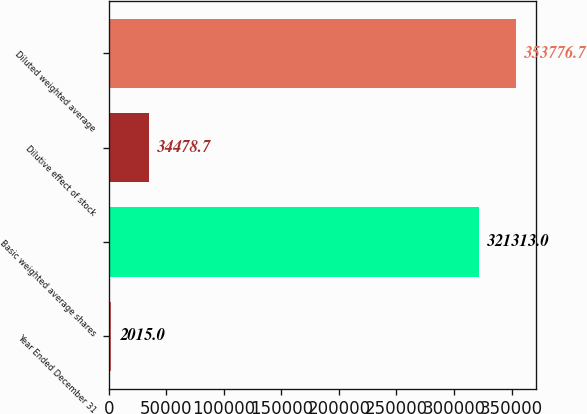Convert chart to OTSL. <chart><loc_0><loc_0><loc_500><loc_500><bar_chart><fcel>Year Ended December 31<fcel>Basic weighted average shares<fcel>Dilutive effect of stock<fcel>Diluted weighted average<nl><fcel>2015<fcel>321313<fcel>34478.7<fcel>353777<nl></chart> 